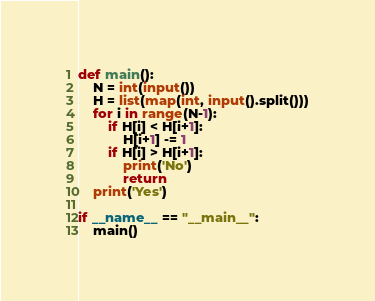<code> <loc_0><loc_0><loc_500><loc_500><_Python_>def main():
    N = int(input())
    H = list(map(int, input().split()))
    for i in range(N-1):
        if H[i] < H[i+1]:
            H[i+1] -= 1
        if H[i] > H[i+1]:
            print('No')
            return
    print('Yes')

if __name__ == "__main__":
    main()
</code> 